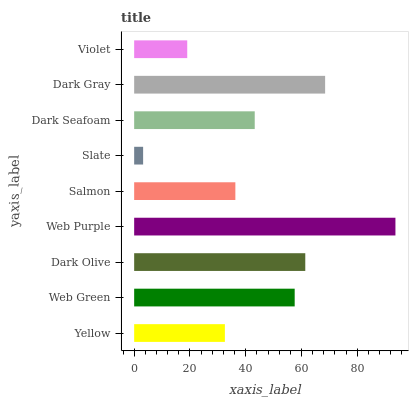Is Slate the minimum?
Answer yes or no. Yes. Is Web Purple the maximum?
Answer yes or no. Yes. Is Web Green the minimum?
Answer yes or no. No. Is Web Green the maximum?
Answer yes or no. No. Is Web Green greater than Yellow?
Answer yes or no. Yes. Is Yellow less than Web Green?
Answer yes or no. Yes. Is Yellow greater than Web Green?
Answer yes or no. No. Is Web Green less than Yellow?
Answer yes or no. No. Is Dark Seafoam the high median?
Answer yes or no. Yes. Is Dark Seafoam the low median?
Answer yes or no. Yes. Is Dark Olive the high median?
Answer yes or no. No. Is Slate the low median?
Answer yes or no. No. 